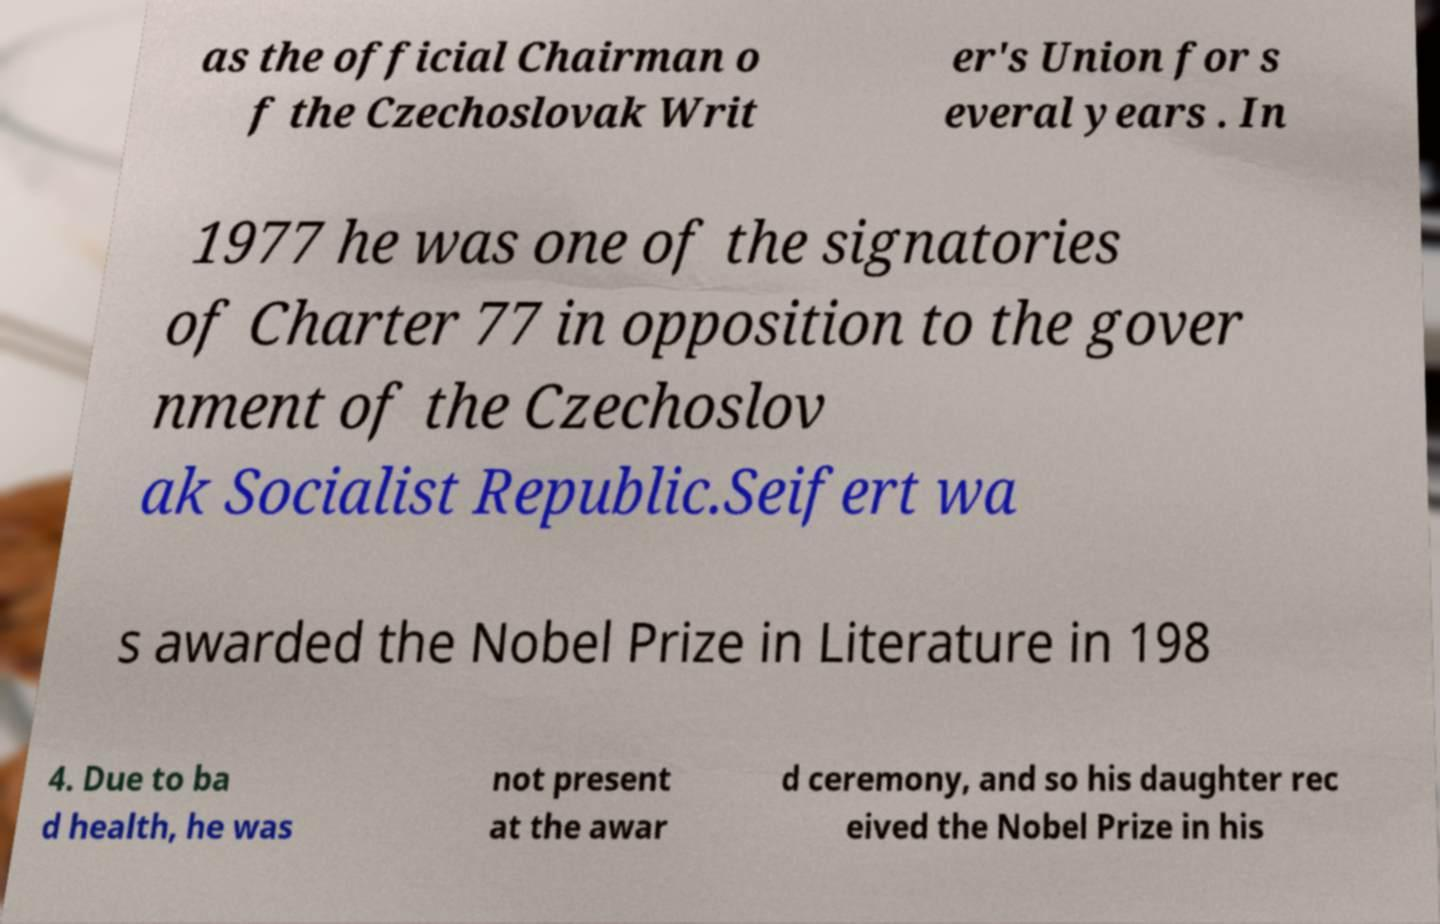Could you assist in decoding the text presented in this image and type it out clearly? as the official Chairman o f the Czechoslovak Writ er's Union for s everal years . In 1977 he was one of the signatories of Charter 77 in opposition to the gover nment of the Czechoslov ak Socialist Republic.Seifert wa s awarded the Nobel Prize in Literature in 198 4. Due to ba d health, he was not present at the awar d ceremony, and so his daughter rec eived the Nobel Prize in his 